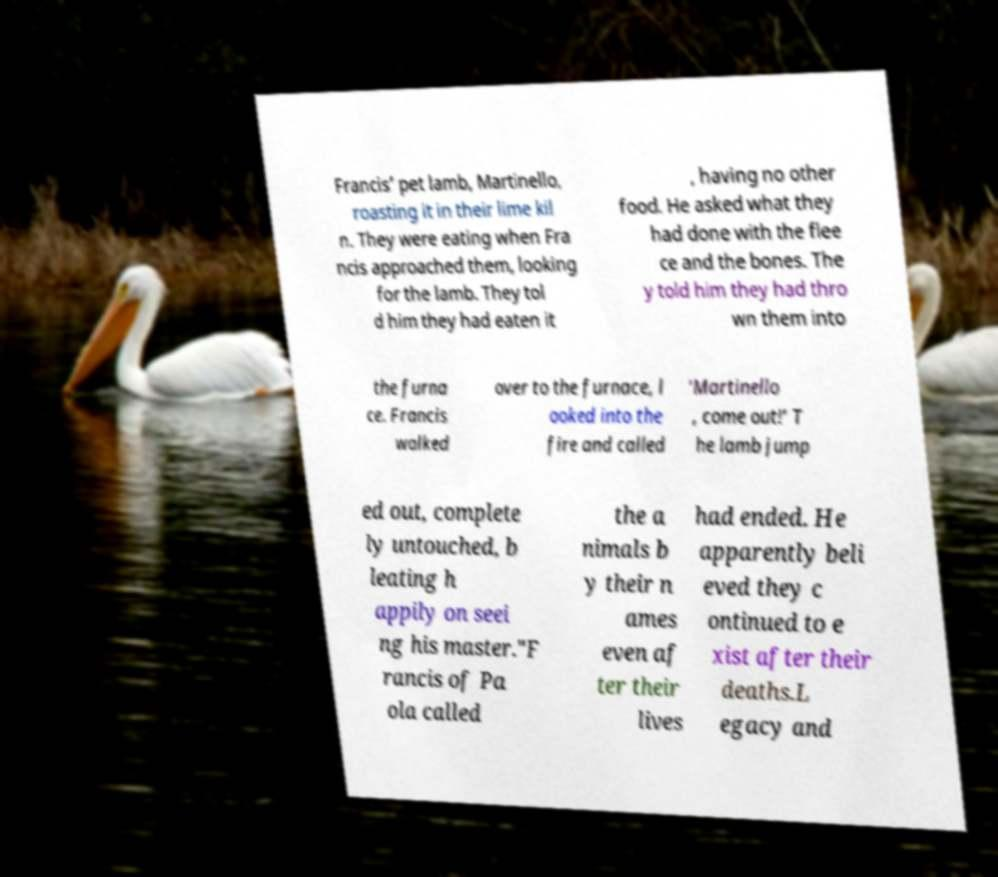Can you accurately transcribe the text from the provided image for me? Francis’ pet lamb, Martinello, roasting it in their lime kil n. They were eating when Fra ncis approached them, looking for the lamb. They tol d him they had eaten it , having no other food. He asked what they had done with the flee ce and the bones. The y told him they had thro wn them into the furna ce. Francis walked over to the furnace, l ooked into the fire and called ‘Martinello , come out!’ T he lamb jump ed out, complete ly untouched, b leating h appily on seei ng his master."F rancis of Pa ola called the a nimals b y their n ames even af ter their lives had ended. He apparently beli eved they c ontinued to e xist after their deaths.L egacy and 